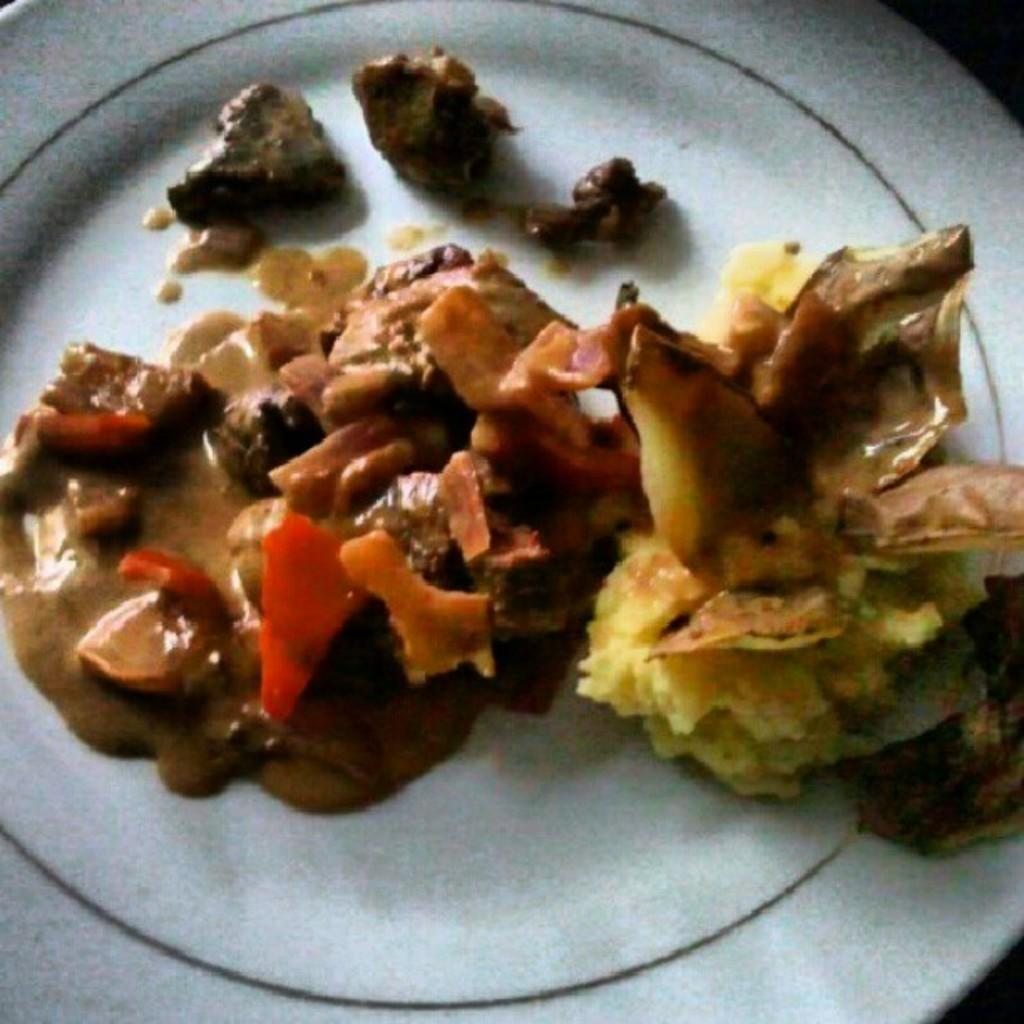What is the main subject of the image? There is a food item on a plate in the image. What type of calculator is being used to prepare the food in the image? There is no calculator present in the image, and the food is already on a plate. Can you see a toad sitting on the food item in the image? There is no toad present in the image; it only features a food item on a plate. 